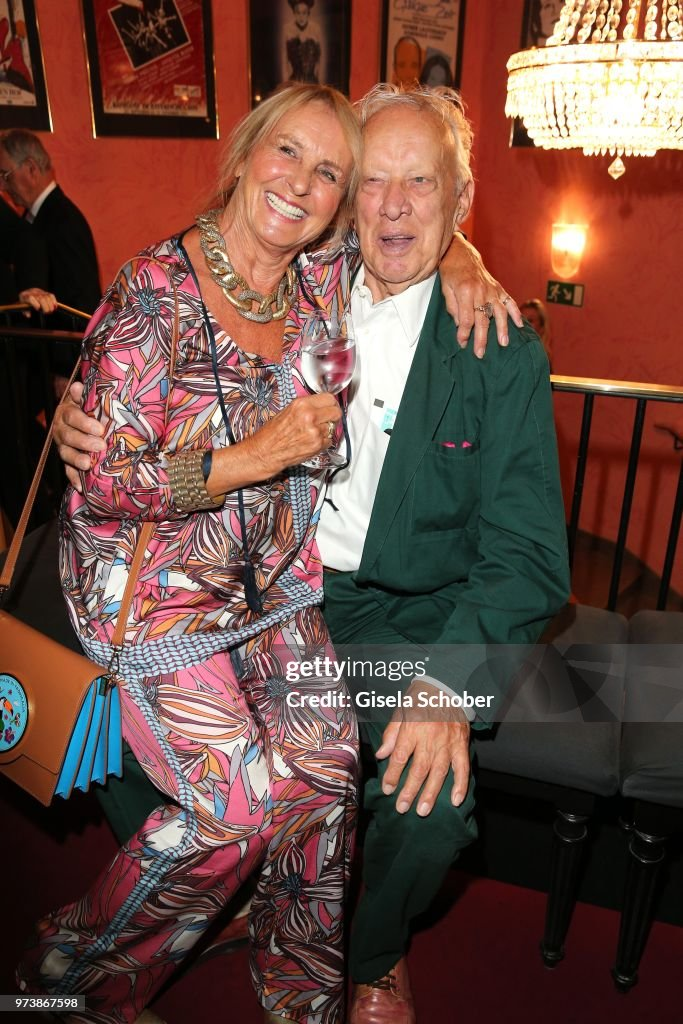Describe the couple's attire and what it might suggest about their personalities. The woman is dressed in a vibrant, patterned dress paired with a statement necklace and a colorful handbag, suggesting she enjoys bold fashion choices and exudes a lively and outgoing personality. Her wide smile and engaging body language further emphasize her friendly and extroverted nature. The man, in contrast, is wearing a more subdued green suit, which, while less flashy, still indicates a certain level of sophistication and comfort. His relaxed demeanor, coupled with his understated but stylish clothing, indicates a calm, laid-back personality, content to let the woman shine while he enjoys her company and the environment. If they were characters in a novel, how would you describe their relationship and backstory? In the vibrant tapestry of the novel, this couple represents a seasoned relationship filled with mutual respect, deep love, and shared adventures. They met decades ago at a similar artistic event, where her exuberance and his quiet charm forged an unbreakable bond. Over the years, they've traveled the world, collecting experiences and stories, each adventure bringing them closer. Their relationship is a beautiful balance of vibrant energy and calm wisdom, a testament to how opposites can indeed form the most enthralling unions. Their presence at this event is not just participation but a celebration of a life lived passionately and harmoniously. 